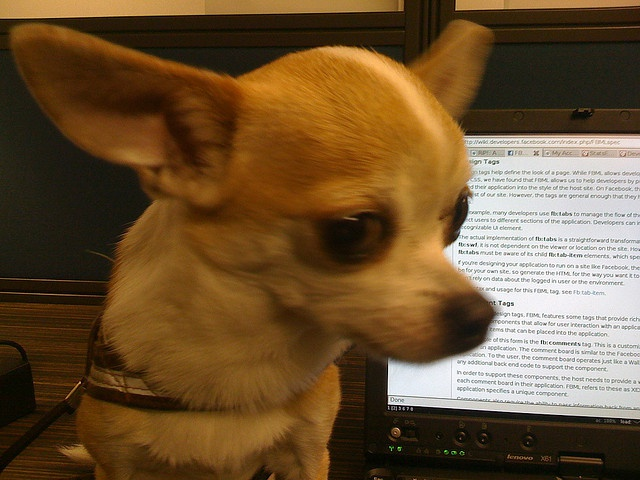Describe the objects in this image and their specific colors. I can see dog in tan, maroon, olive, and black tones, laptop in tan, lightgray, black, darkgray, and maroon tones, and tv in tan, lightgray, black, darkgray, and maroon tones in this image. 